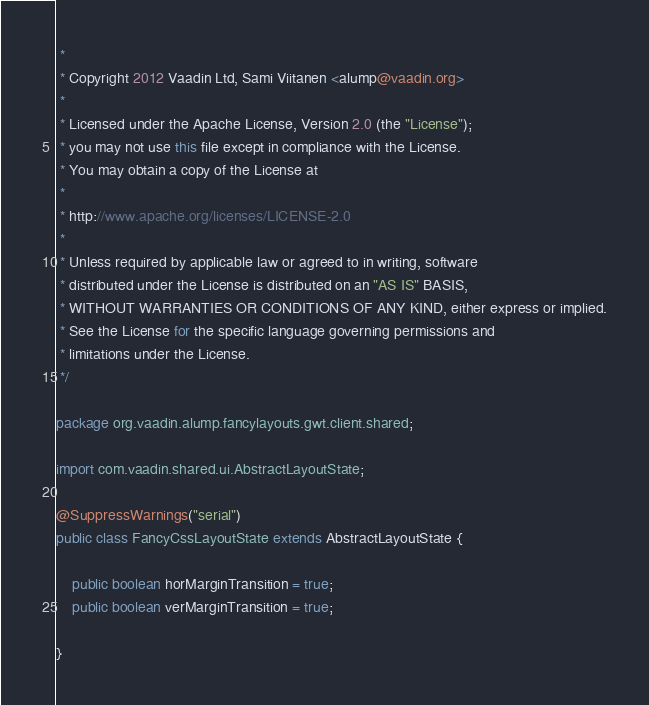Convert code to text. <code><loc_0><loc_0><loc_500><loc_500><_Java_> * 
 * Copyright 2012 Vaadin Ltd, Sami Viitanen <alump@vaadin.org>
 *
 * Licensed under the Apache License, Version 2.0 (the "License");
 * you may not use this file except in compliance with the License.
 * You may obtain a copy of the License at
 *
 * http://www.apache.org/licenses/LICENSE-2.0
 *
 * Unless required by applicable law or agreed to in writing, software
 * distributed under the License is distributed on an "AS IS" BASIS,
 * WITHOUT WARRANTIES OR CONDITIONS OF ANY KIND, either express or implied.
 * See the License for the specific language governing permissions and
 * limitations under the License.
 */

package org.vaadin.alump.fancylayouts.gwt.client.shared;

import com.vaadin.shared.ui.AbstractLayoutState;

@SuppressWarnings("serial")
public class FancyCssLayoutState extends AbstractLayoutState {

    public boolean horMarginTransition = true;
    public boolean verMarginTransition = true;

}
</code> 